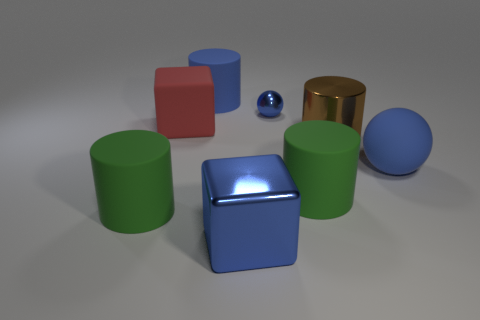Are there fewer red matte objects that are right of the tiny blue shiny ball than large matte blocks?
Offer a very short reply. Yes. What material is the green cylinder on the right side of the large shiny cube?
Your answer should be compact. Rubber. What number of other objects are there of the same size as the metal block?
Offer a terse response. 6. Is the number of large red metal spheres less than the number of red things?
Keep it short and to the point. Yes. What is the shape of the brown thing?
Provide a short and direct response. Cylinder. Do the rubber cylinder behind the metal cylinder and the small thing have the same color?
Your answer should be very brief. Yes. The large thing that is in front of the large blue cylinder and behind the brown shiny cylinder has what shape?
Provide a succinct answer. Cube. What color is the sphere that is in front of the big brown thing?
Provide a short and direct response. Blue. Are there any other things that are the same color as the metal ball?
Your response must be concise. Yes. Is the blue metallic ball the same size as the blue cylinder?
Keep it short and to the point. No. 